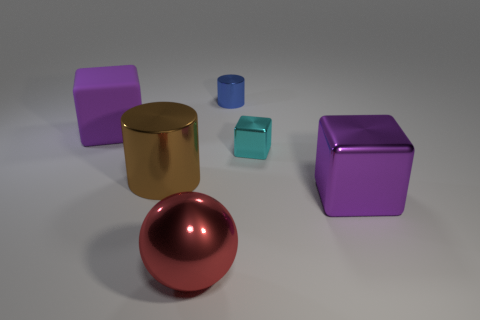Subtract all purple blocks. How many blocks are left? 1 Subtract all cyan balls. How many purple blocks are left? 2 Add 1 large brown objects. How many objects exist? 7 Subtract all cylinders. How many objects are left? 4 Add 6 rubber cubes. How many rubber cubes are left? 7 Add 1 gray cylinders. How many gray cylinders exist? 1 Subtract 1 blue cylinders. How many objects are left? 5 Subtract all gray blocks. Subtract all yellow cylinders. How many blocks are left? 3 Subtract all large things. Subtract all tiny shiny objects. How many objects are left? 0 